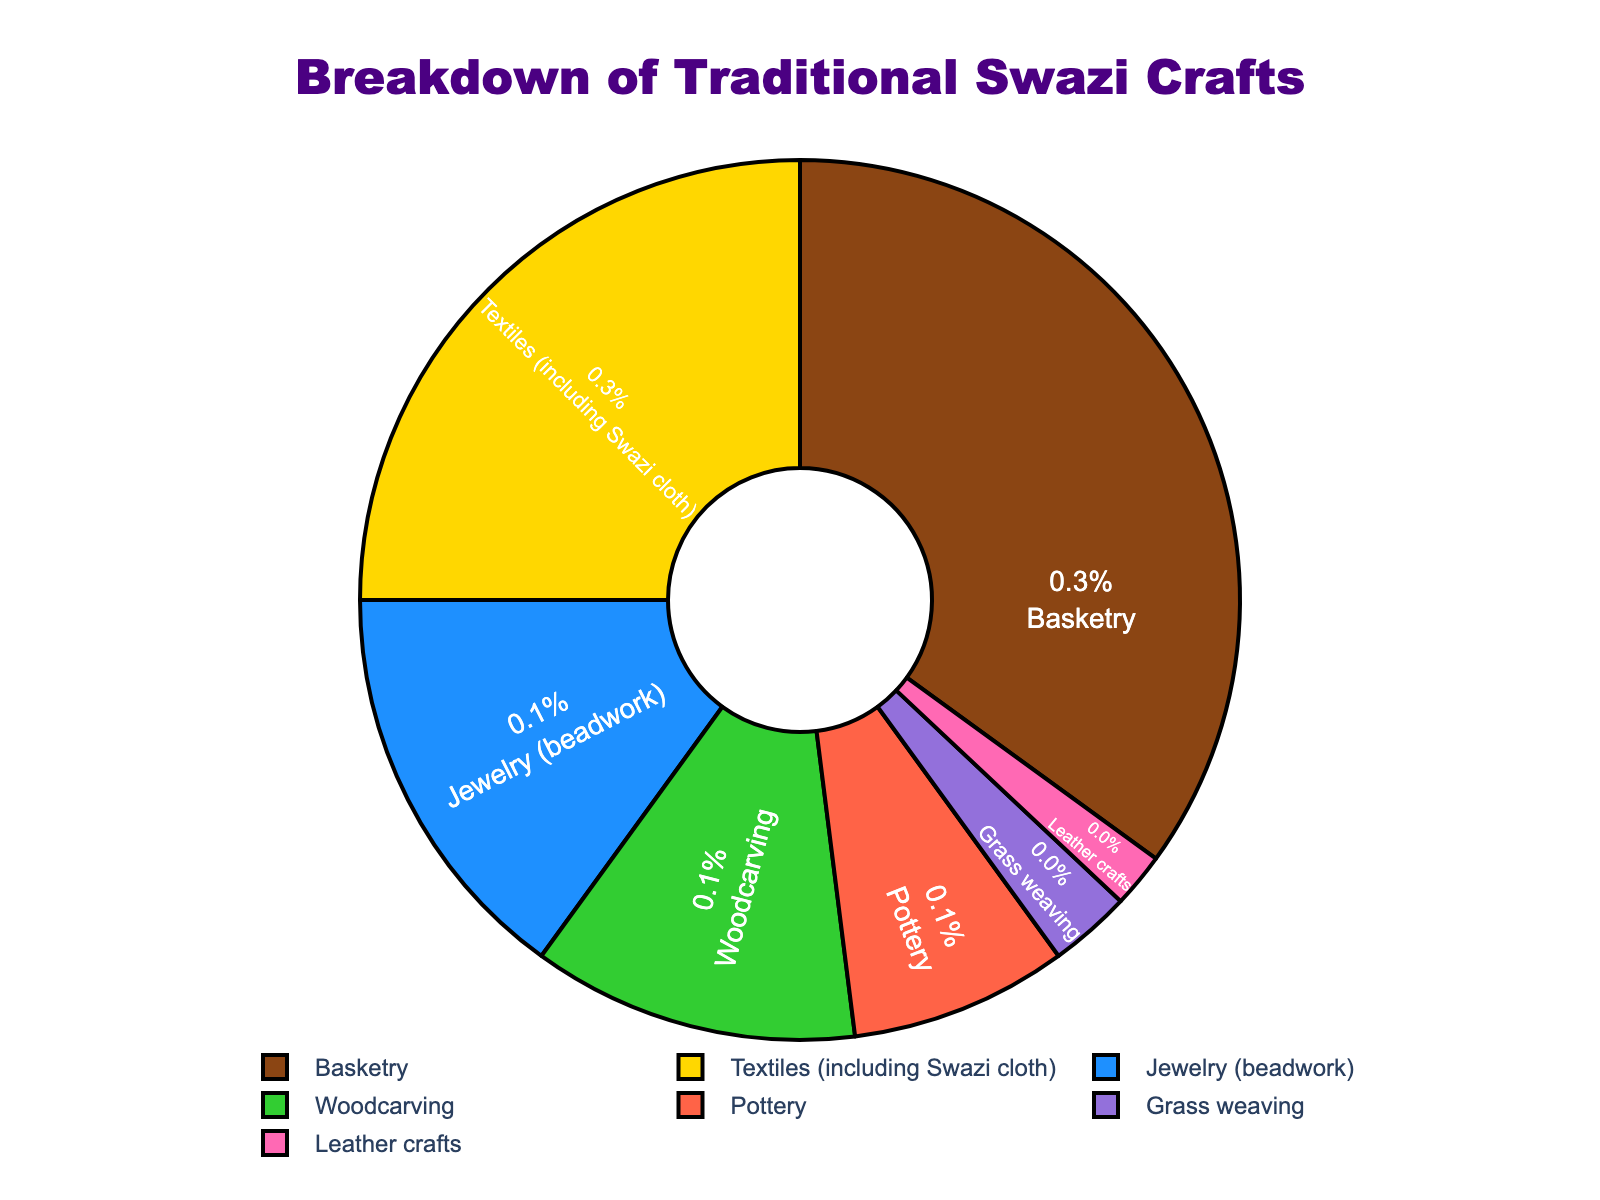What is the largest category in the pie chart? The pie chart shows that Basketry has the largest slice, occupying 35% of the total. Hence, Basketry is the largest category.
Answer: Basketry What is the combined percentage of Pottery and Grass weaving? According to the pie chart, Pottery accounts for 8% and Grass weaving for 3%. Adding these together gives 8% + 3% = 11%.
Answer: 11% Which category has a higher percentage, Jewelry (beadwork) or Woodcarving? The pie chart shows Jewelry (beadwork) at 15% and Woodcarving at 12%. Therefore, Jewelry (beadwork) has a higher percentage.
Answer: Jewelry (beadwork) How much more percentage does Basketry have compared to Leather crafts? Basketry is 35% and Leather crafts is 2%. The difference is 35% - 2% = 33%.
Answer: 33% What percentage of the crafts are textiles (including Swazi cloth) according to the pie chart? The pie chart indicates that Textiles (including Swazi cloth) make up 25% of the total.
Answer: 25% Which category is represented with the color green in the pie chart? The pie chart uses colors to distinguish between categories. The green slice represents Woodcarving.
Answer: Woodcarving How much greater is the percentage of Basketry than Textiles (including Swazi cloth)? Basketry stands at 35% while Textiles (including Swazi cloth) is at 25%. The difference is 35% - 25% = 10%.
Answer: 10% What is the total percentage of categories that are less than 10% each? The categories less than 10% are Pottery (8%), Grass weaving (3%), and Leather crafts (2%). Summing these gives 8% + 3% + 2% = 13%.
Answer: 13% If Jewelry (beadwork) and Woodcarving were combined into one category, what percentage would they represent together? Jewelry (beadwork) is 15% and Woodcarving is 12%. Their combined percentage is 15% + 12% = 27%.
Answer: 27% Which categories together make up more than half of the total crafts? Basketry (35%) and Textiles (including Swazi cloth) (25%) together total 35% + 25% = 60%, which is more than half.
Answer: Basketry and Textiles (including Swazi cloth) 